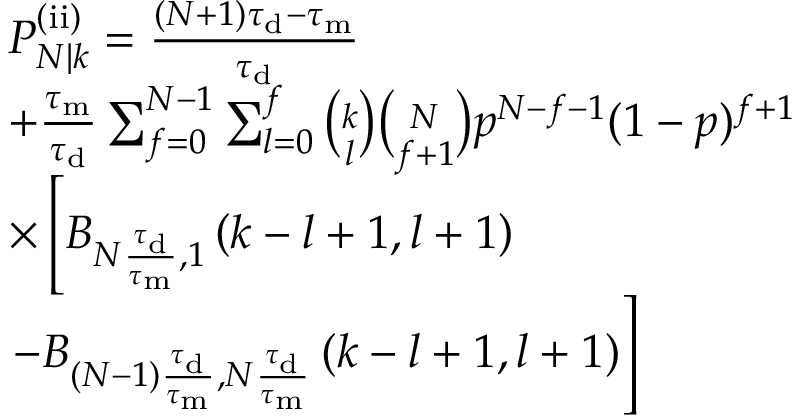Convert formula to latex. <formula><loc_0><loc_0><loc_500><loc_500>\begin{array} { r l } & { P _ { N | k } ^ { ( i i ) } = \frac { ( N + 1 ) \tau _ { d } - \tau _ { m } } { \tau _ { d } } } \\ & { + \frac { \tau _ { m } } { \tau _ { d } } \sum _ { f = 0 } ^ { N - 1 } \sum _ { l = 0 } ^ { f } \binom { k } { l } \binom { N } { f + 1 } p ^ { N - f - 1 } ( 1 - p ) ^ { f + 1 } } \\ & { \times \left [ B _ { N \frac { \tau _ { d } } { \tau _ { m } } , 1 } \left ( k - l + 1 , l + 1 \right ) } \\ & { - B _ { ( N - 1 ) \frac { \tau _ { d } } { \tau _ { m } } , N \frac { \tau _ { d } } { \tau _ { m } } } \left ( k - l + 1 , l + 1 \right ) \right ] } \end{array}</formula> 